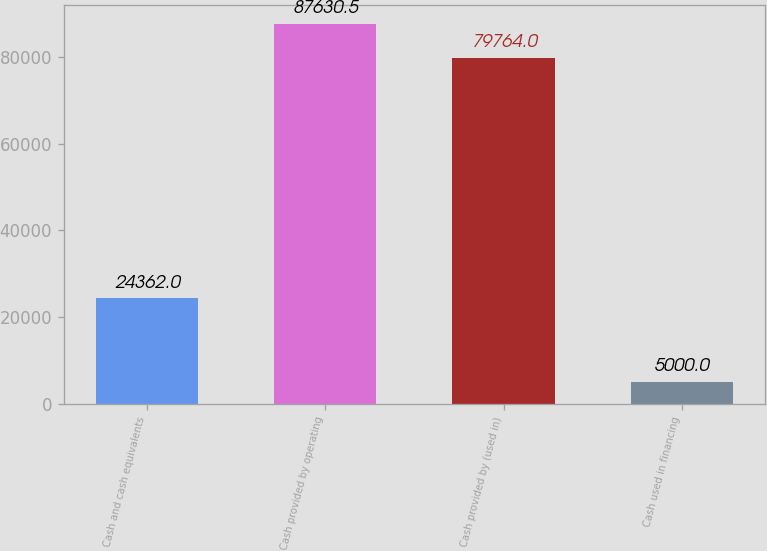Convert chart to OTSL. <chart><loc_0><loc_0><loc_500><loc_500><bar_chart><fcel>Cash and cash equivalents<fcel>Cash provided by operating<fcel>Cash provided by (used in)<fcel>Cash used in financing<nl><fcel>24362<fcel>87630.5<fcel>79764<fcel>5000<nl></chart> 